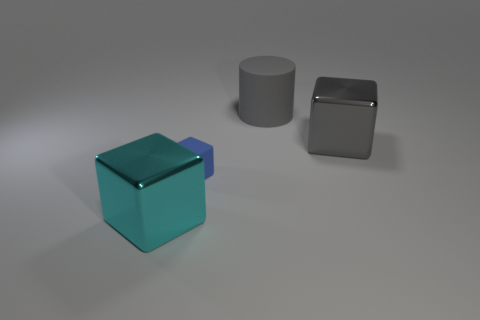The block that is the same color as the large rubber cylinder is what size?
Your answer should be compact. Large. What is the material of the cylinder?
Your answer should be very brief. Rubber. The other cube that is the same size as the gray block is what color?
Provide a short and direct response. Cyan. There is a metal object that is the same color as the large matte cylinder; what shape is it?
Make the answer very short. Cube. Does the small thing have the same shape as the cyan metallic thing?
Offer a terse response. Yes. The big object that is both in front of the large rubber cylinder and on the right side of the blue matte block is made of what material?
Provide a short and direct response. Metal. What is the size of the rubber cylinder?
Your answer should be very brief. Large. What is the color of the tiny thing that is the same shape as the large gray metal thing?
Offer a terse response. Blue. Is there any other thing that has the same color as the tiny thing?
Provide a succinct answer. No. Do the matte thing that is on the right side of the tiny thing and the shiny object that is to the left of the rubber cylinder have the same size?
Your answer should be very brief. Yes. 